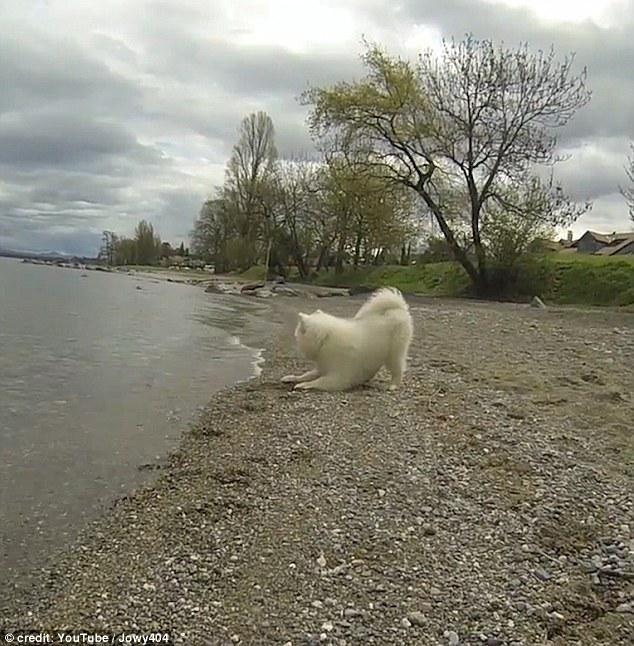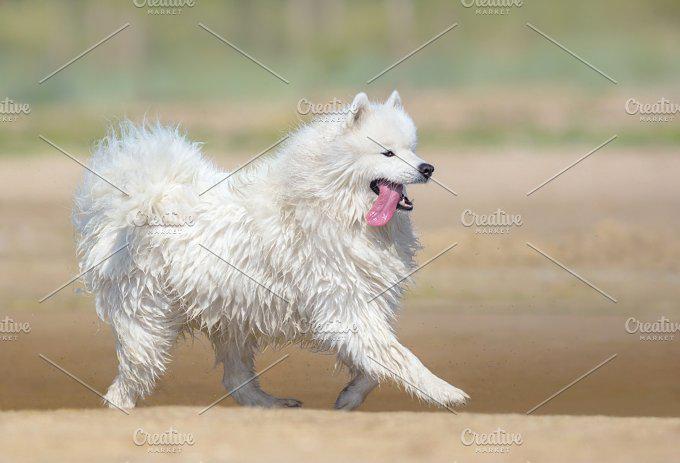The first image is the image on the left, the second image is the image on the right. For the images shown, is this caption "A white dog is standing on the rocky shore of a beach." true? Answer yes or no. Yes. The first image is the image on the left, the second image is the image on the right. Analyze the images presented: Is the assertion "The right image includes at least twice the number of dogs as the left image." valid? Answer yes or no. No. 